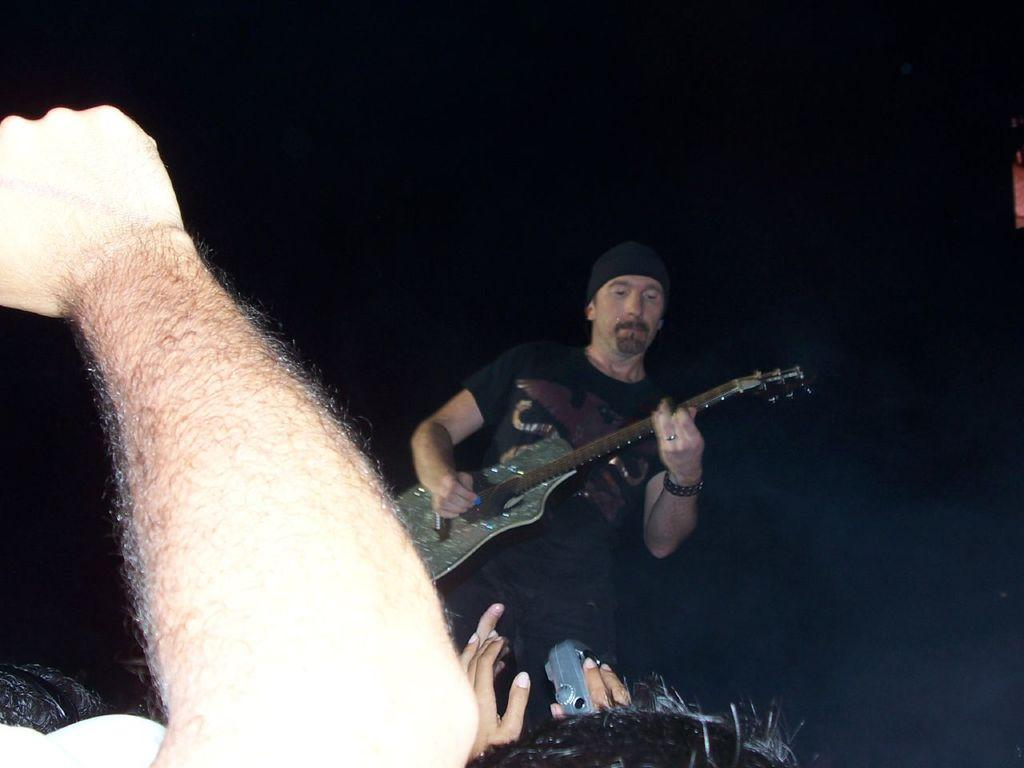What is the man in the image doing? The man is playing the guitar in the image. How many people are present in the image? There is a group of persons standing in the image. What activity are the people engaged in? The man is playing the guitar, but we cannot determine the activity of the other persons from the given facts. What type of salt is being used by the man playing the guitar in the image? There is no salt present in the image, and the man is not using any salt while playing the guitar. 